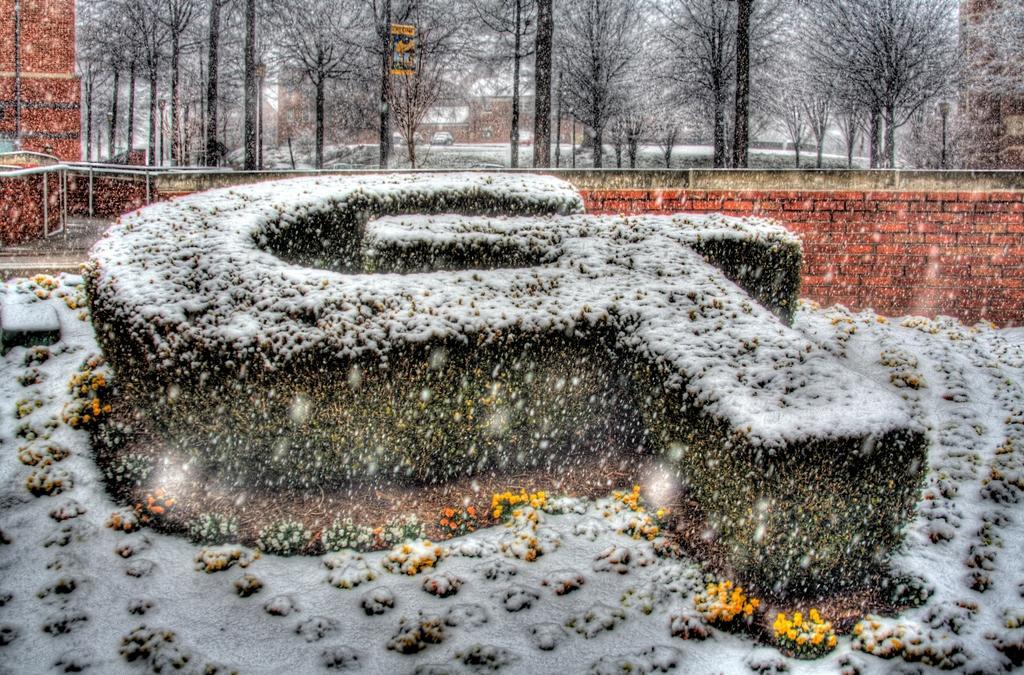How would you summarize this image in a sentence or two? Here in this picture we can see bushes present on the ground and around it we can see some flower plants also present, that are fully covered with snow and behind that we can see a wall and railing present and in the far we can see plants and trees present and we can see the place is fully covered with snow fall. 